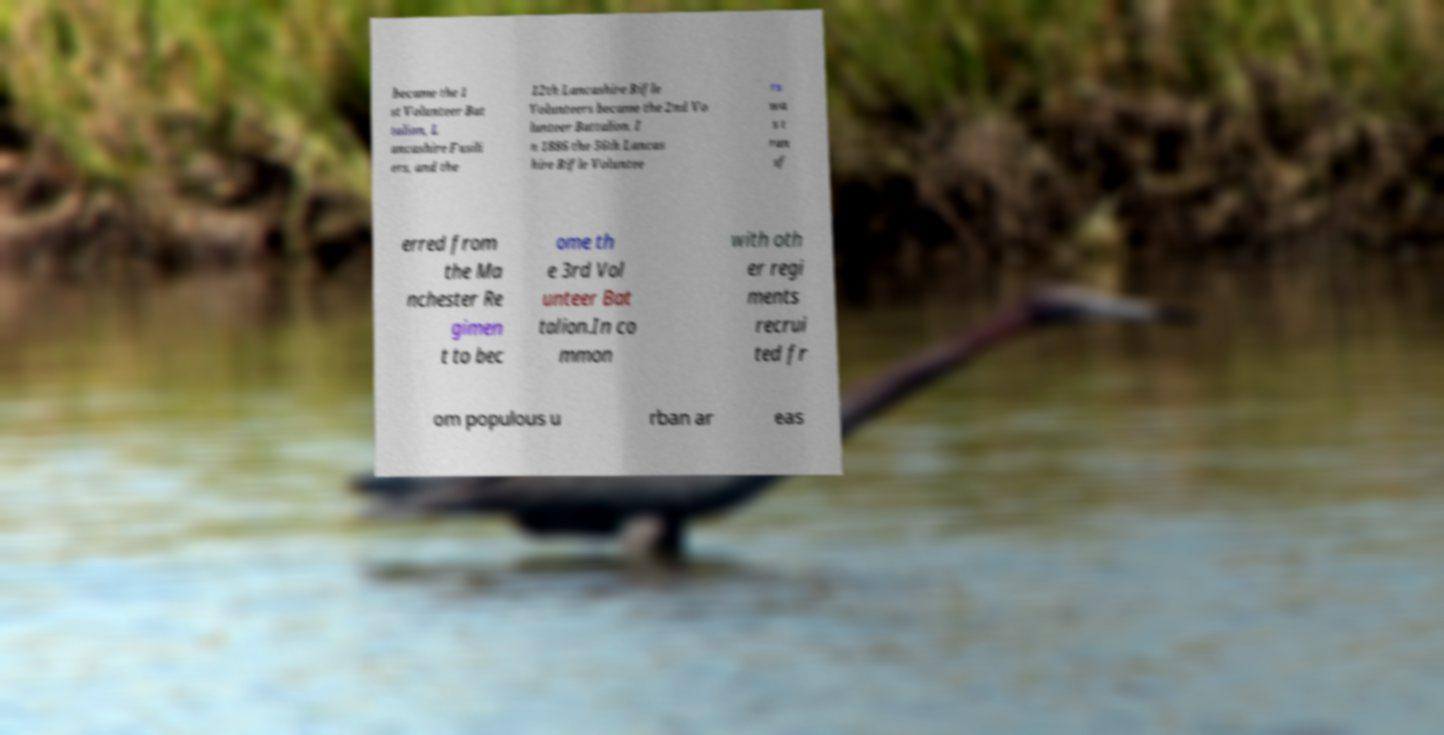Please read and relay the text visible in this image. What does it say? became the 1 st Volunteer Bat talion, L ancashire Fusili ers, and the 12th Lancashire Rifle Volunteers became the 2nd Vo lunteer Battalion. I n 1886 the 56th Lancas hire Rifle Voluntee rs wa s t ran sf erred from the Ma nchester Re gimen t to bec ome th e 3rd Vol unteer Bat talion.In co mmon with oth er regi ments recrui ted fr om populous u rban ar eas 